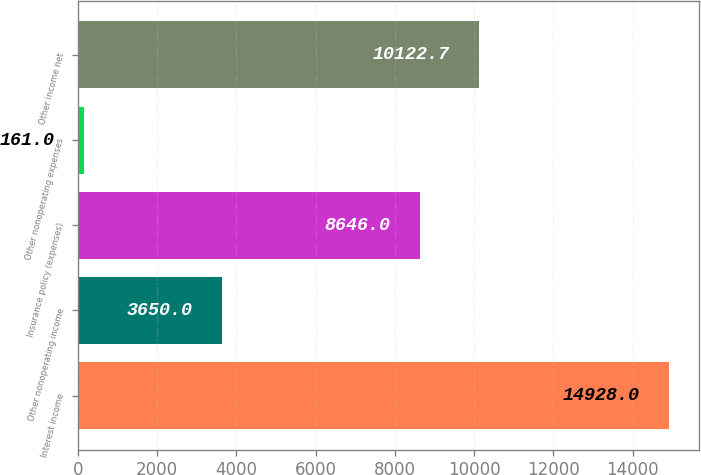Convert chart. <chart><loc_0><loc_0><loc_500><loc_500><bar_chart><fcel>Interest income<fcel>Other nonoperating income<fcel>Insurance policy (expenses)<fcel>Other nonoperating expenses<fcel>Other income net<nl><fcel>14928<fcel>3650<fcel>8646<fcel>161<fcel>10122.7<nl></chart> 